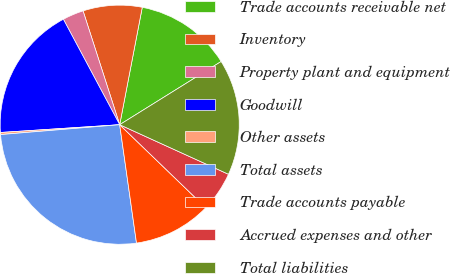Convert chart. <chart><loc_0><loc_0><loc_500><loc_500><pie_chart><fcel>Trade accounts receivable net<fcel>Inventory<fcel>Property plant and equipment<fcel>Goodwill<fcel>Other assets<fcel>Total assets<fcel>Trade accounts payable<fcel>Accrued expenses and other<fcel>Total liabilities<nl><fcel>13.11%<fcel>7.98%<fcel>2.85%<fcel>18.23%<fcel>0.28%<fcel>25.93%<fcel>10.54%<fcel>5.41%<fcel>15.67%<nl></chart> 